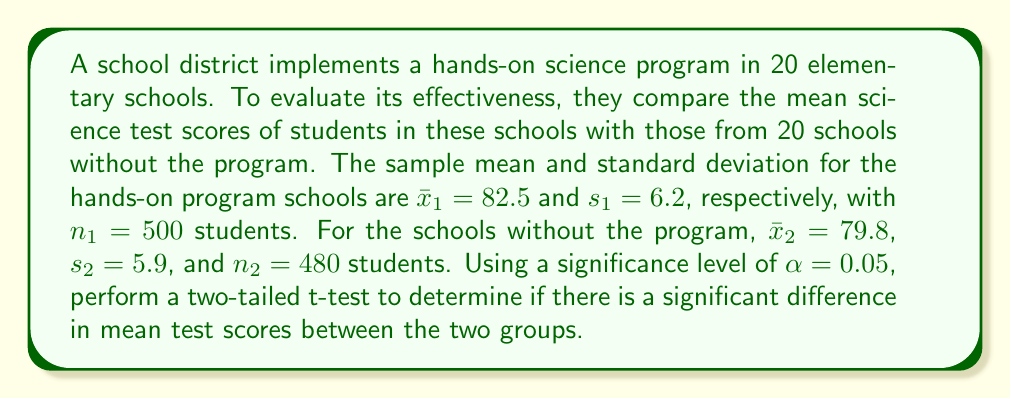Help me with this question. To analyze the effectiveness of the hands-on learning program, we'll use a two-sample t-test. The steps are as follows:

1. State the null and alternative hypotheses:
   $H_0: \mu_1 - \mu_2 = 0$ (no difference in means)
   $H_a: \mu_1 - \mu_2 \neq 0$ (there is a difference in means)

2. Calculate the pooled standard error:
   $$SE = \sqrt{\frac{s_1^2}{n_1} + \frac{s_2^2}{n_2}} = \sqrt{\frac{6.2^2}{500} + \frac{5.9^2}{480}} = 0.3896$$

3. Calculate the t-statistic:
   $$t = \frac{(\bar{x}_1 - \bar{x}_2) - 0}{SE} = \frac{82.5 - 79.8}{0.3896} = 6.9301$$

4. Determine the degrees of freedom:
   $$df = n_1 + n_2 - 2 = 500 + 480 - 2 = 978$$

5. Find the critical t-value for a two-tailed test with $\alpha = 0.05$ and $df = 978$:
   $t_{crit} = \pm 1.9625$ (using a t-distribution table or calculator)

6. Compare the calculated t-statistic to the critical value:
   $|6.9301| > 1.9625$, so we reject the null hypothesis.

7. Calculate the p-value:
   $p < 0.0001$ (using a t-distribution calculator)

Since the calculated t-statistic (6.9301) is greater in absolute value than the critical t-value (1.9625), and the p-value (< 0.0001) is less than the significance level (0.05), we reject the null hypothesis.
Answer: Reject the null hypothesis. There is strong evidence to suggest that there is a significant difference in mean test scores between schools with and without the hands-on science program (t(978) = 6.9301, p < 0.0001). The data indicates that the hands-on program is associated with higher mean test scores. 